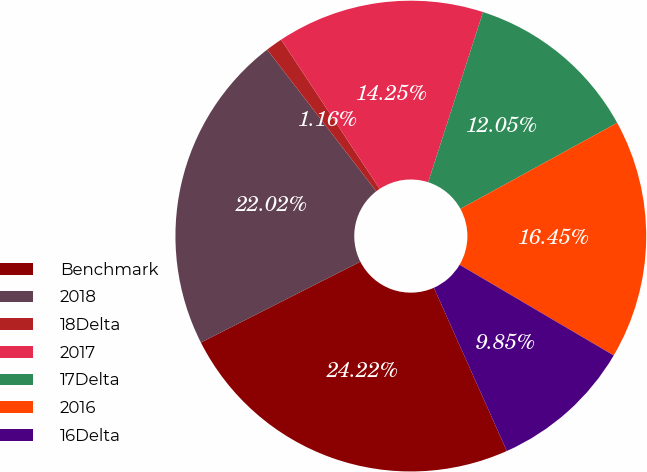Convert chart. <chart><loc_0><loc_0><loc_500><loc_500><pie_chart><fcel>Benchmark<fcel>2018<fcel>18Delta<fcel>2017<fcel>17Delta<fcel>2016<fcel>16Delta<nl><fcel>24.22%<fcel>22.02%<fcel>1.16%<fcel>14.25%<fcel>12.05%<fcel>16.45%<fcel>9.85%<nl></chart> 